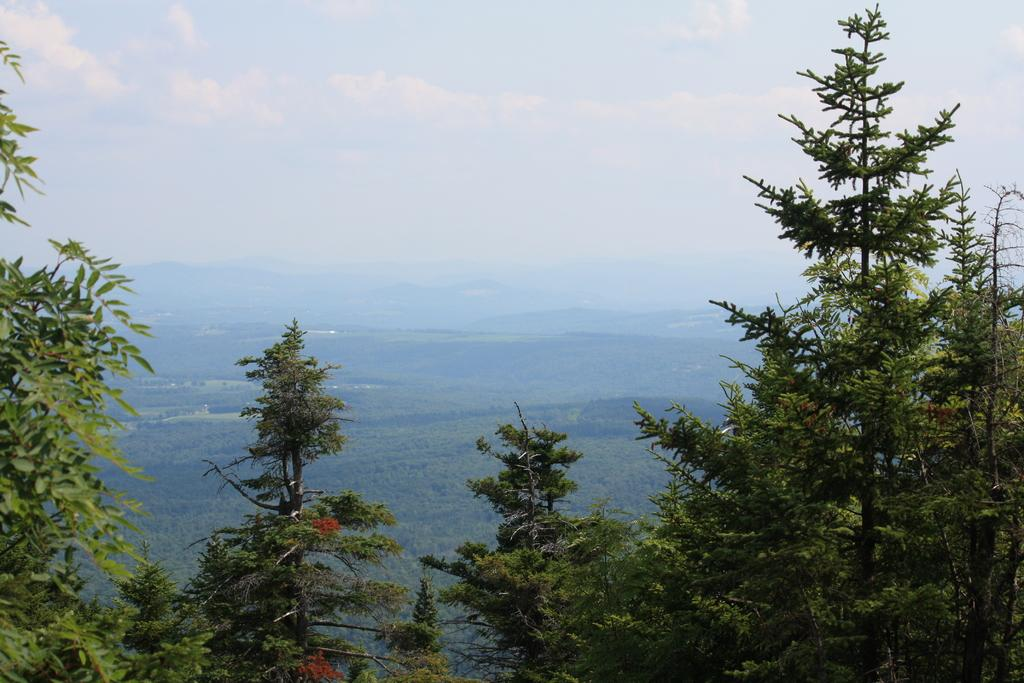What type of vegetation can be seen in the front of the image? There are trees in the front of the image. How many trees are visible in the background of the image? There are multiple trees in the background of the image. What type of geographical feature can be seen in the background of the image? There are mountains visible in the background of the image. What else can be seen in the background of the image? There are clouds and the sky visible in the background of the image. How far does the clam travel in the image? There is no clam present in the image, so it cannot travel any distance. 